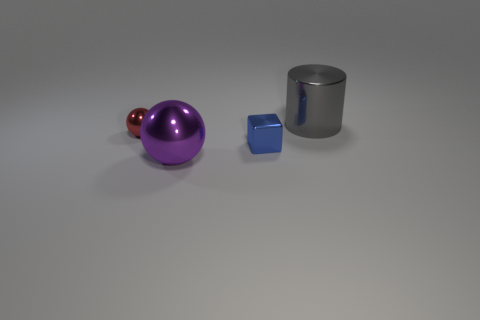How many metallic things are the same size as the purple shiny ball?
Keep it short and to the point. 1. What color is the metal object that is on the left side of the blue shiny block and in front of the tiny red thing?
Your response must be concise. Purple. Is the number of large yellow matte spheres less than the number of large cylinders?
Provide a succinct answer. Yes. Do the small block and the big metal thing that is behind the blue object have the same color?
Keep it short and to the point. No. Are there the same number of big balls behind the red thing and metal cubes that are behind the tiny block?
Your answer should be compact. Yes. How many other tiny shiny objects have the same shape as the blue thing?
Provide a short and direct response. 0. Is there a tiny matte block?
Provide a succinct answer. No. Do the cube and the large thing that is behind the large purple metallic object have the same material?
Offer a very short reply. Yes. There is a sphere that is the same size as the cylinder; what is it made of?
Your answer should be compact. Metal. Is there a large cylinder made of the same material as the tiny cube?
Your answer should be very brief. Yes. 